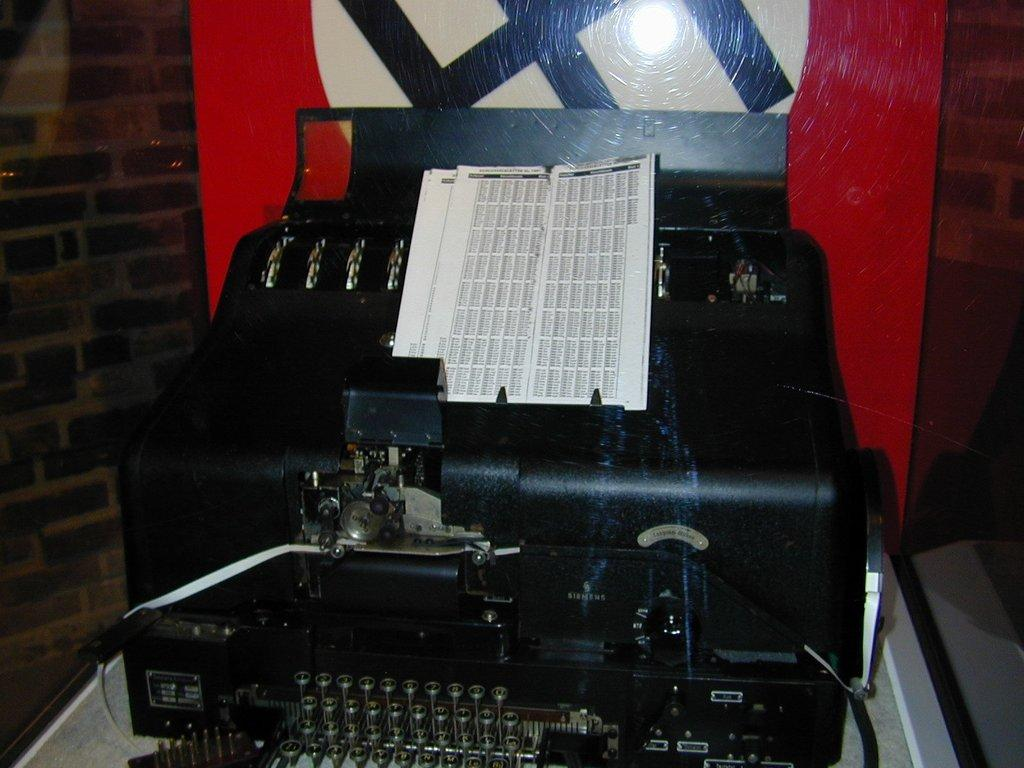What type of object is the main subject of the image? There is an electronic device in the image. Can you describe the setting or environment in which the electronic device is located? There is a wall visible in the background of the image. What type of needle is being used to implement the idea in the image? There is no needle or idea present in the image; it only features an electronic device and a wall in the background. 